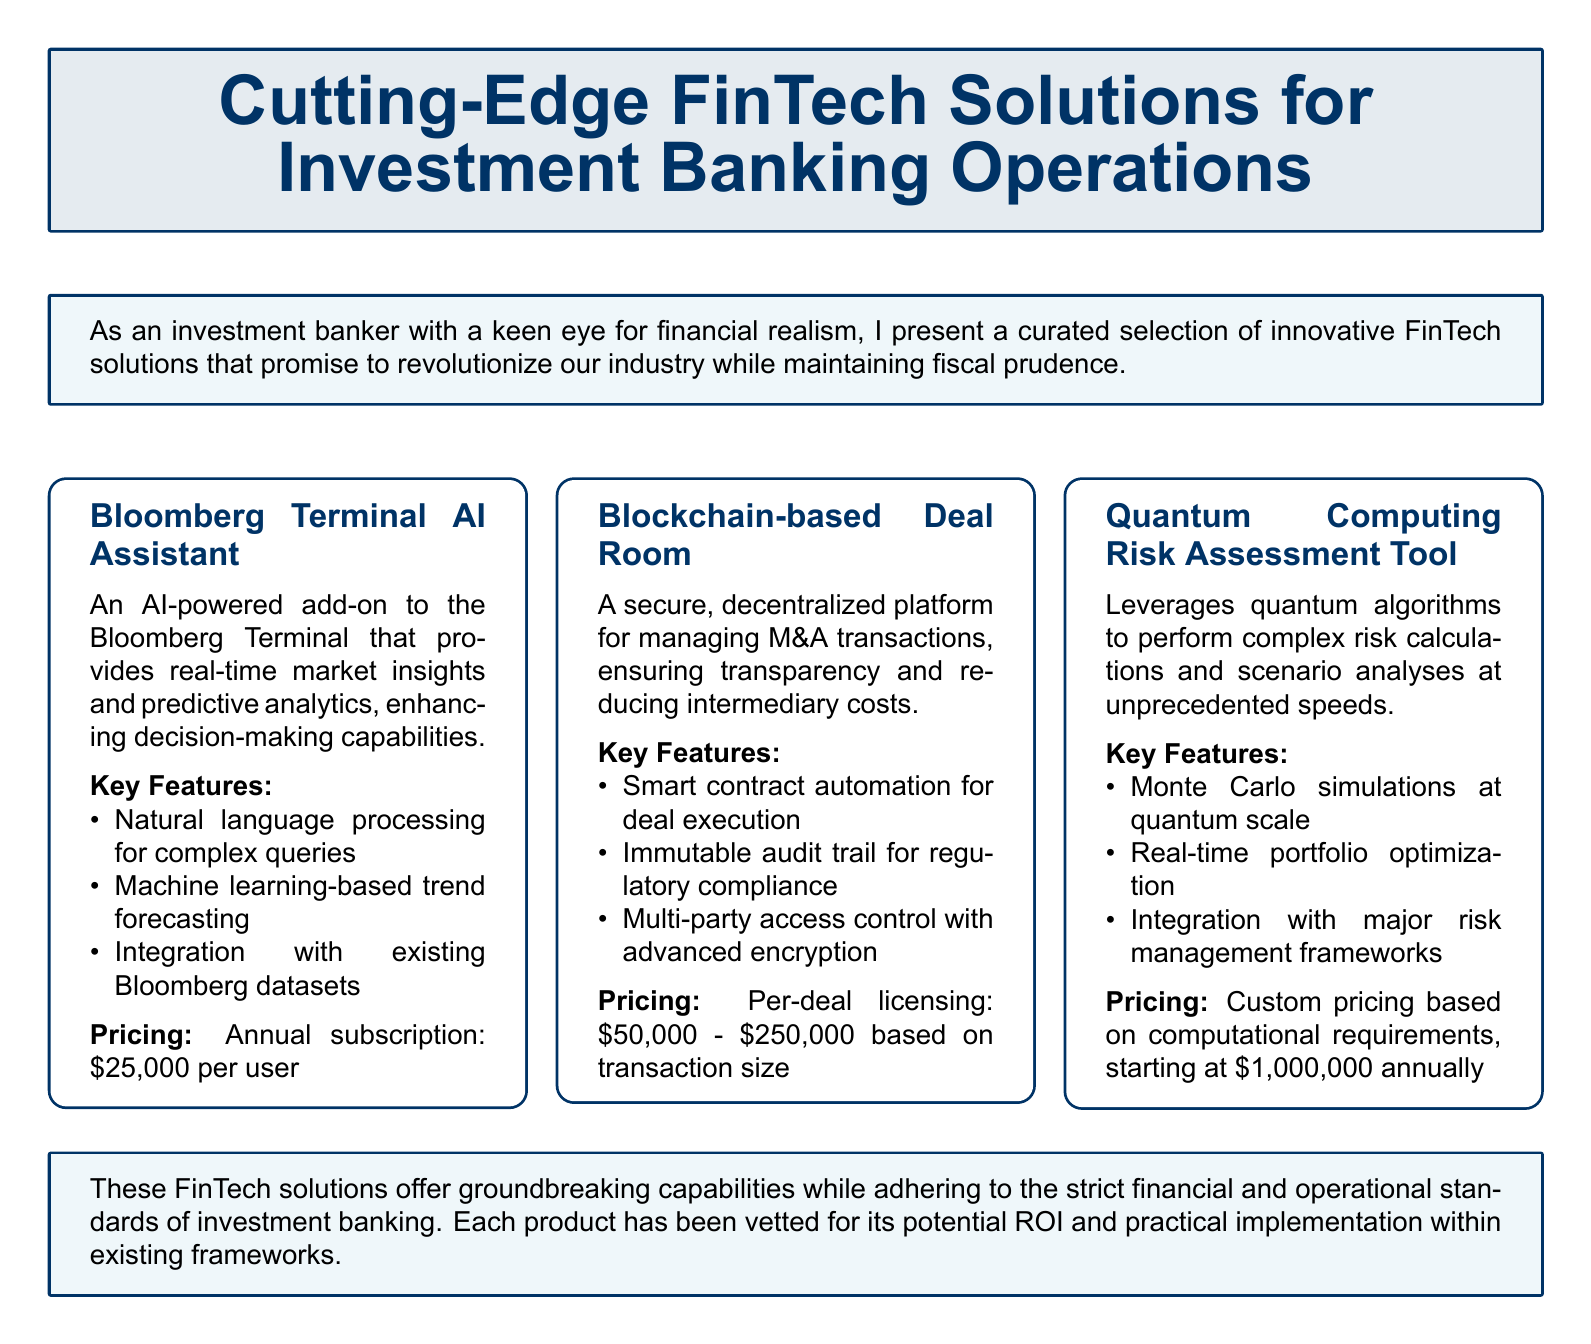What is the title of the catalog? The title of the catalog is presented prominently at the top of the document.
Answer: Cutting-Edge FinTech Solutions for Investment Banking Operations What is the annual subscription cost for the Bloomberg Terminal AI Assistant? The pricing section specifies the cost for the Bloomberg Terminal AI Assistant.
Answer: 25,000 per user What key feature is associated with the Blockchain-based Deal Room? The key features listed include capabilities related to the Blockchain-based Deal Room.
Answer: Smart contract automation for deal execution What custom pricing starts at which amount for the Quantum Computing Risk Assessment Tool? The document indicates the starting price for custom pricing of the Quantum Computing Risk Assessment Tool.
Answer: 1,000,000 annually What type of platform does the Blockchain-based Deal Room offer? The description of the Blockchain-based Deal Room indicates its function as a platform.
Answer: Decentralized What is one aspect that all listed FinTech solutions are vetted for? The concluding section of the document mentions a consideration for all FinTech solutions.
Answer: Potential ROI Which FinTech solution offers predictive analytics? The description of the solution reveals its analytical capabilities.
Answer: Bloomberg Terminal AI Assistant How many products are featured in the catalog? The catalog shows a total of specific FinTech solutions listed within it.
Answer: Three 